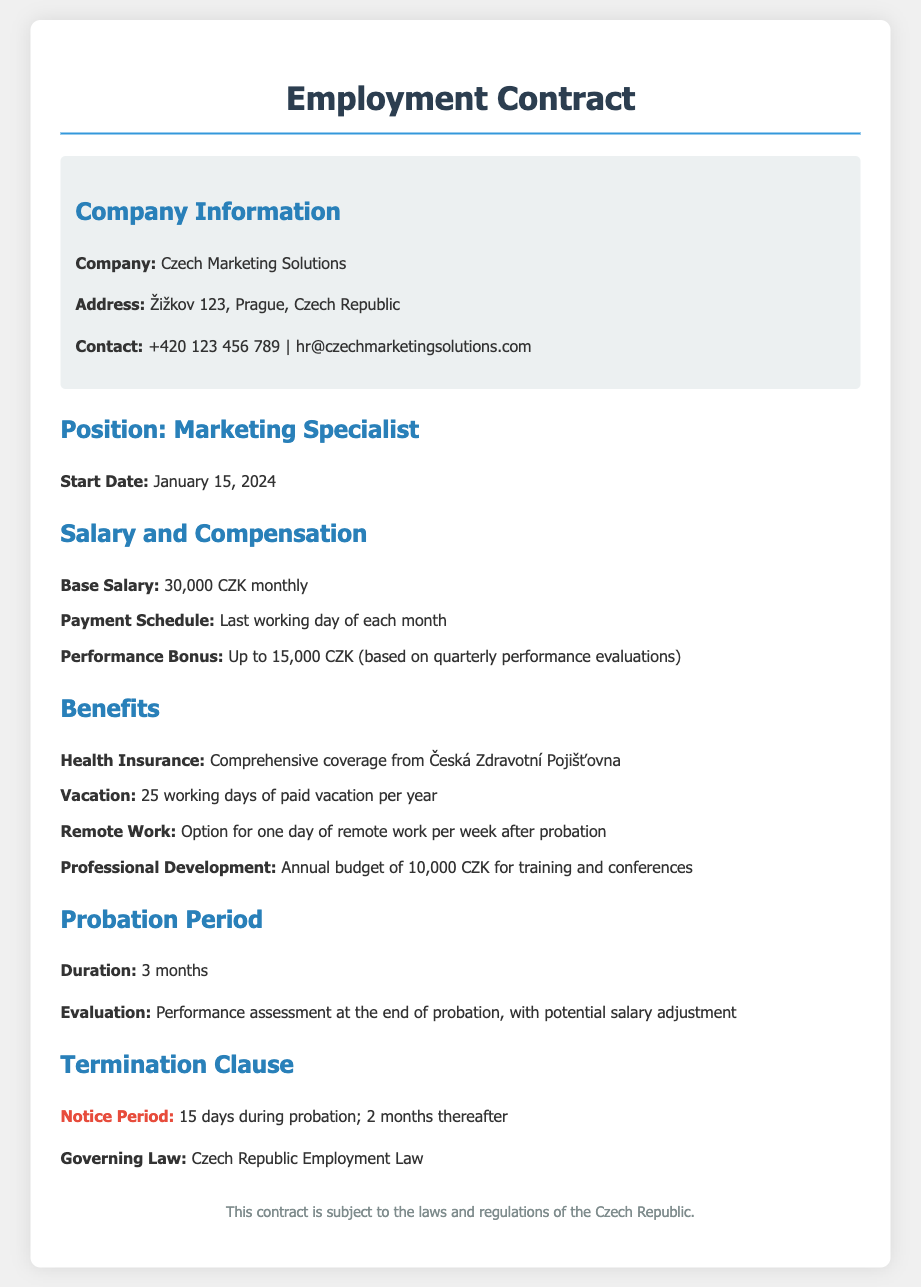What is the base salary? The base salary is listed in the document under Salary and Compensation, indicating the monthly payment for the position.
Answer: 30,000 CZK monthly What is the duration of the probation period? The document specifies the length of the probation period in the Probation Period section.
Answer: 3 months What is the evaluation criteria at the end of the probation? The document states how performance will be assessed at the end of the probation period, indicating the potential outcome regarding salary.
Answer: Performance assessment What is the payment schedule? The payment schedule for salary disbursement is outlined in the Salary and Compensation section.
Answer: Last working day of each month How many days of vacation are provided per year? The document mentions the number of vacation days available in the Benefits section.
Answer: 25 working days What is the maximum performance bonus? The maximum performance bonus is detailed in the Salary and Compensation section, showing the potential extra earnings based on performance.
Answer: Up to 15,000 CZK What is the contact email for the company? The contact information includes an email address provided in the Company Information section.
Answer: hr@czechmarketingsolutions.com What is the notice period during probation? The document specifies the notice period applicable during the probationary phase in the Termination Clause.
Answer: 15 days 